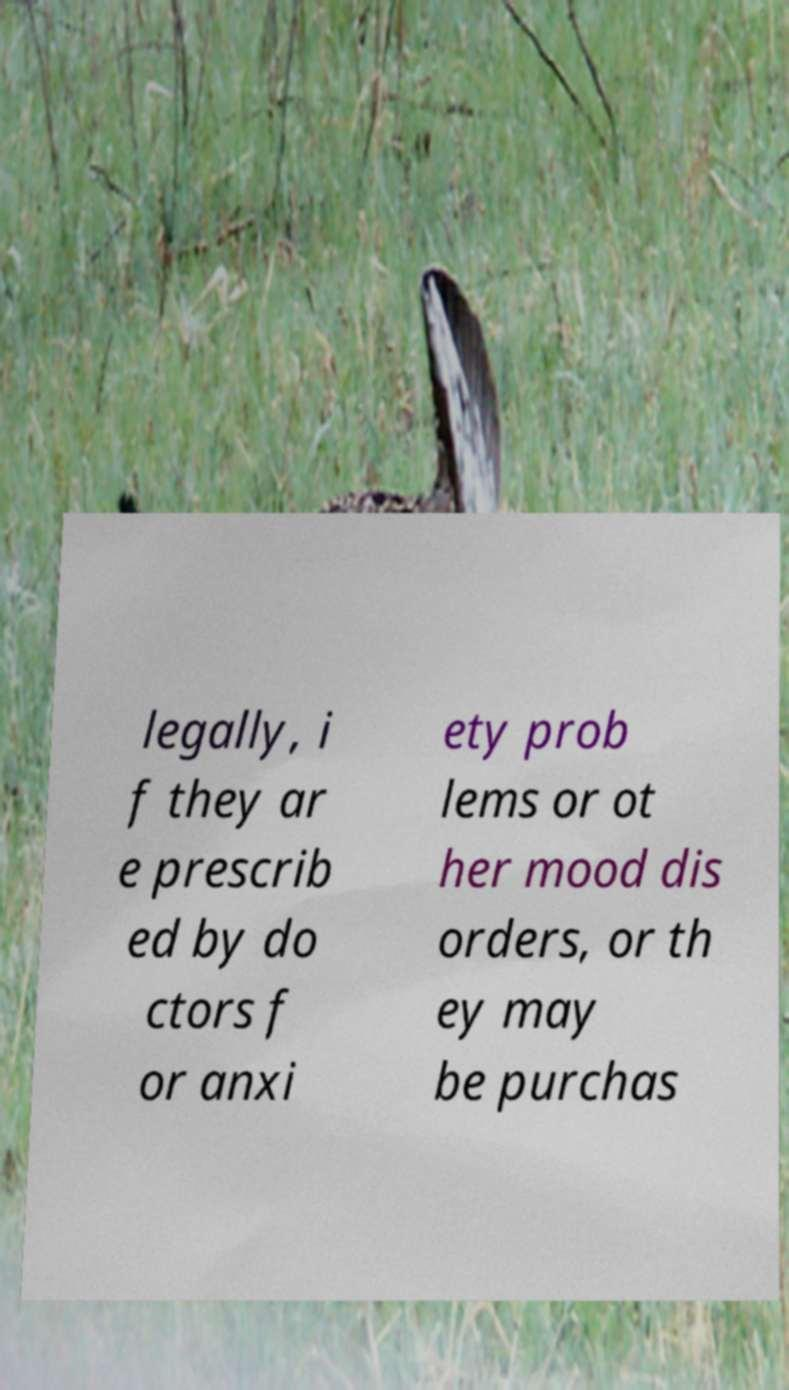Can you accurately transcribe the text from the provided image for me? legally, i f they ar e prescrib ed by do ctors f or anxi ety prob lems or ot her mood dis orders, or th ey may be purchas 